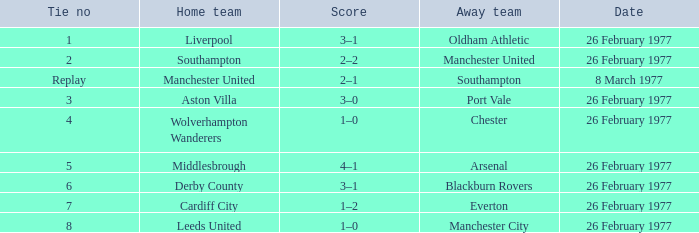In the replay of the tied game, what was the final score? 2–1. 